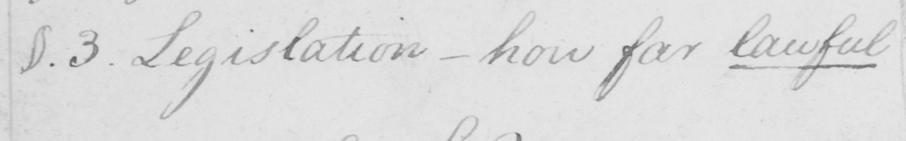Please transcribe the handwritten text in this image. §.3 . Legislation  _  how far lawful 